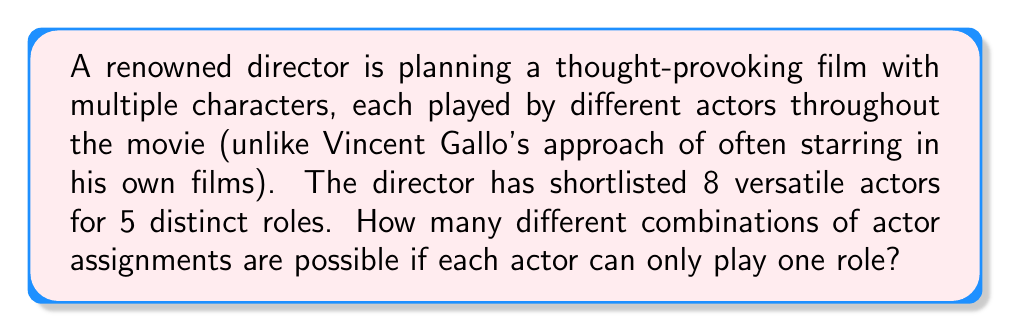Give your solution to this math problem. Let's approach this step-by-step:

1) This is a permutation problem, as the order matters (which actor is assigned to which role).

2) We are selecting 5 actors out of 8, where each selection reduces the available pool for the next role.

3) The formula for this type of permutation is:

   $$P(n,r) = \frac{n!}{(n-r)!}$$

   Where $n$ is the total number of items to choose from, and $r$ is the number of items being chosen.

4) In this case, $n = 8$ (total actors) and $r = 5$ (roles to be filled).

5) Plugging these values into our formula:

   $$P(8,5) = \frac{8!}{(8-5)!} = \frac{8!}{3!}$$

6) Expanding this:
   
   $$\frac{8 * 7 * 6 * 5 * 4 * 3!}{3!}$$

7) The $3!$ cancels out in the numerator and denominator:

   $$8 * 7 * 6 * 5 * 4 = 6720$$

Therefore, there are 6720 different possible combinations of actor assignments for the 5 roles.
Answer: 6720 